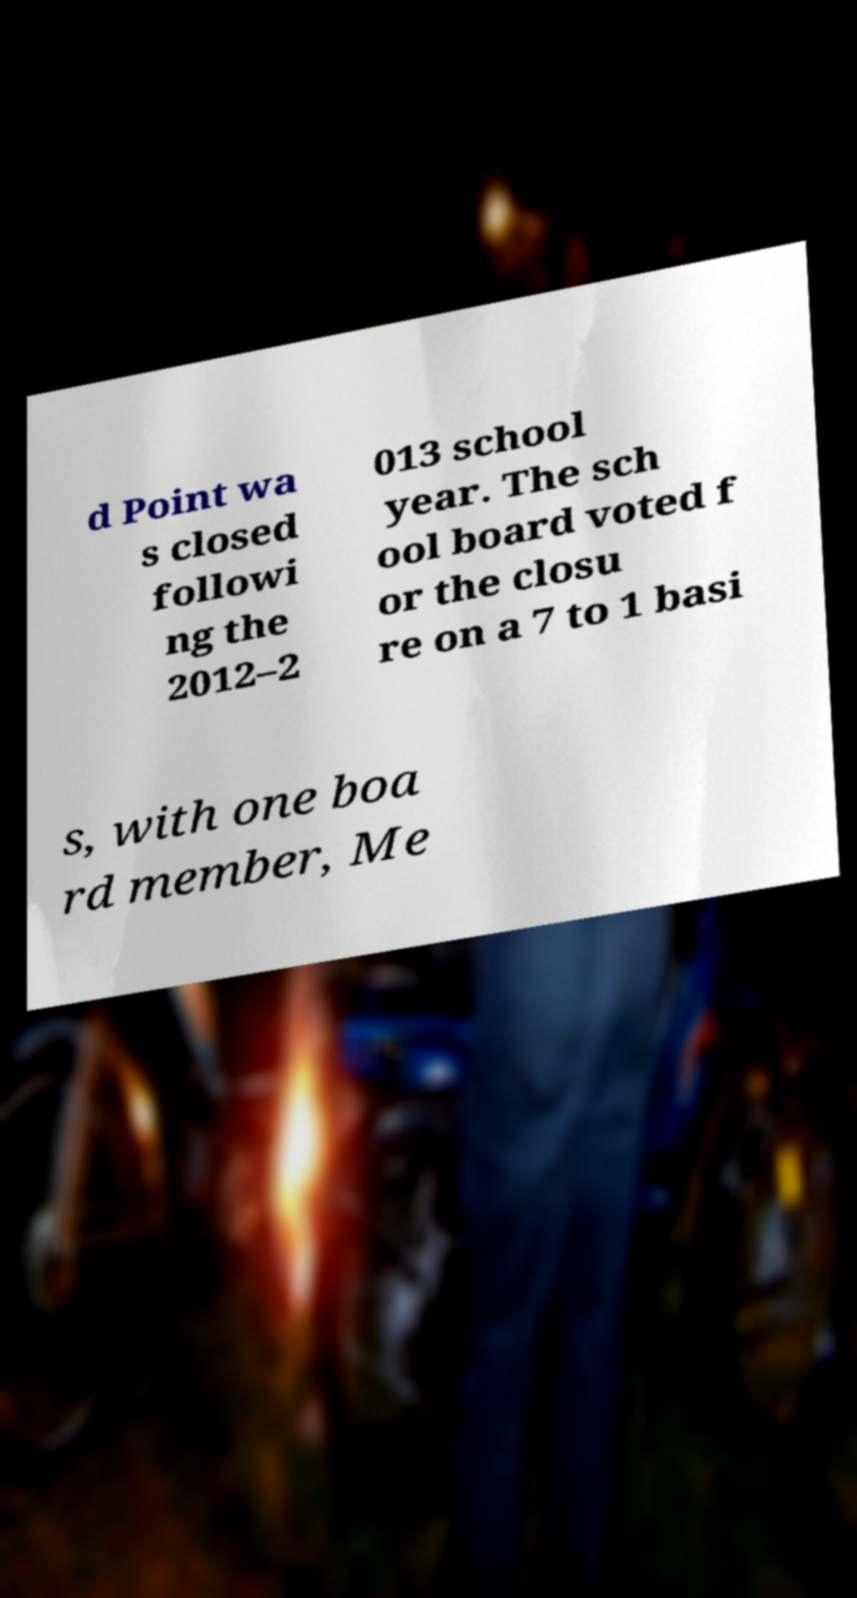For documentation purposes, I need the text within this image transcribed. Could you provide that? d Point wa s closed followi ng the 2012–2 013 school year. The sch ool board voted f or the closu re on a 7 to 1 basi s, with one boa rd member, Me 